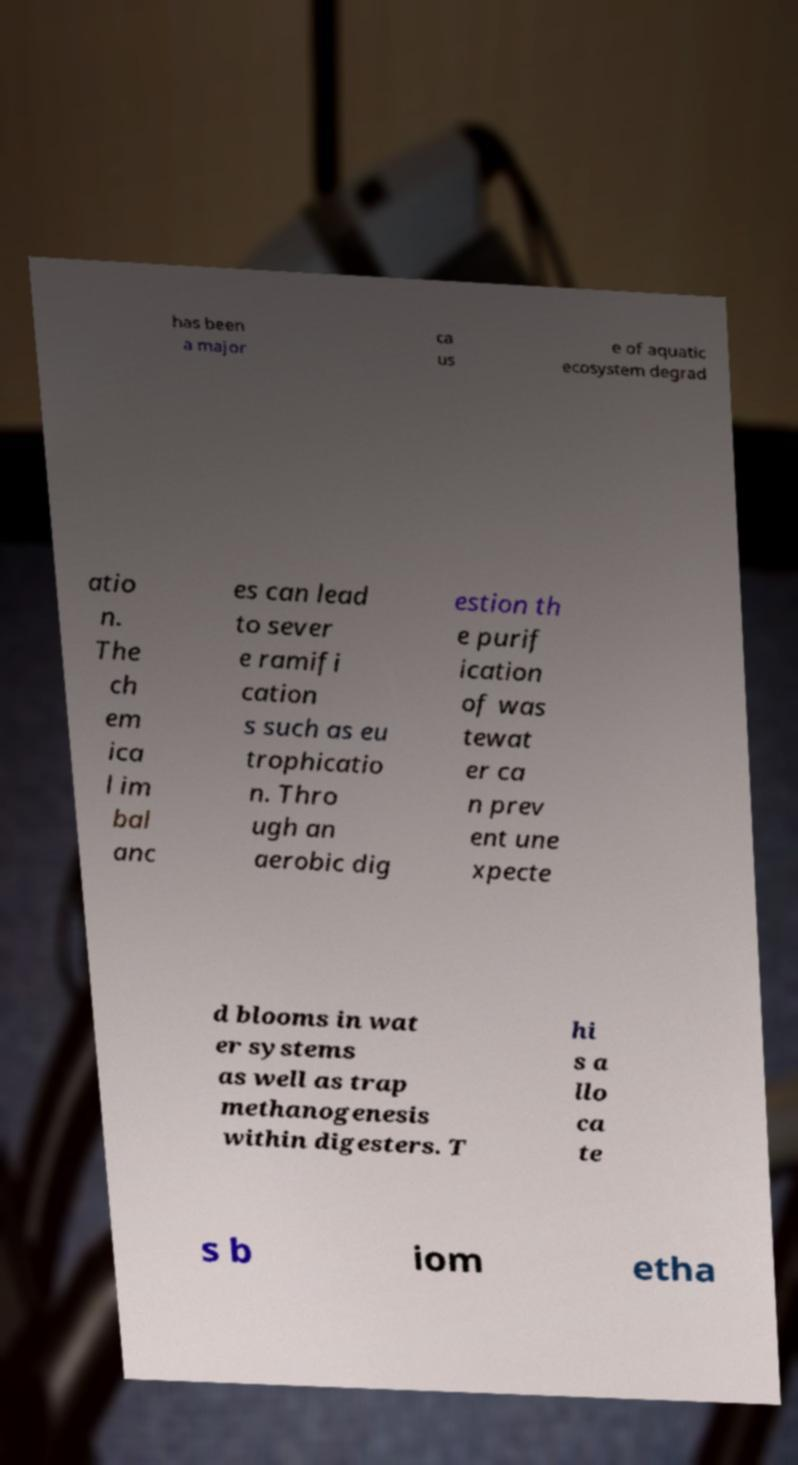Could you extract and type out the text from this image? has been a major ca us e of aquatic ecosystem degrad atio n. The ch em ica l im bal anc es can lead to sever e ramifi cation s such as eu trophicatio n. Thro ugh an aerobic dig estion th e purif ication of was tewat er ca n prev ent une xpecte d blooms in wat er systems as well as trap methanogenesis within digesters. T hi s a llo ca te s b iom etha 